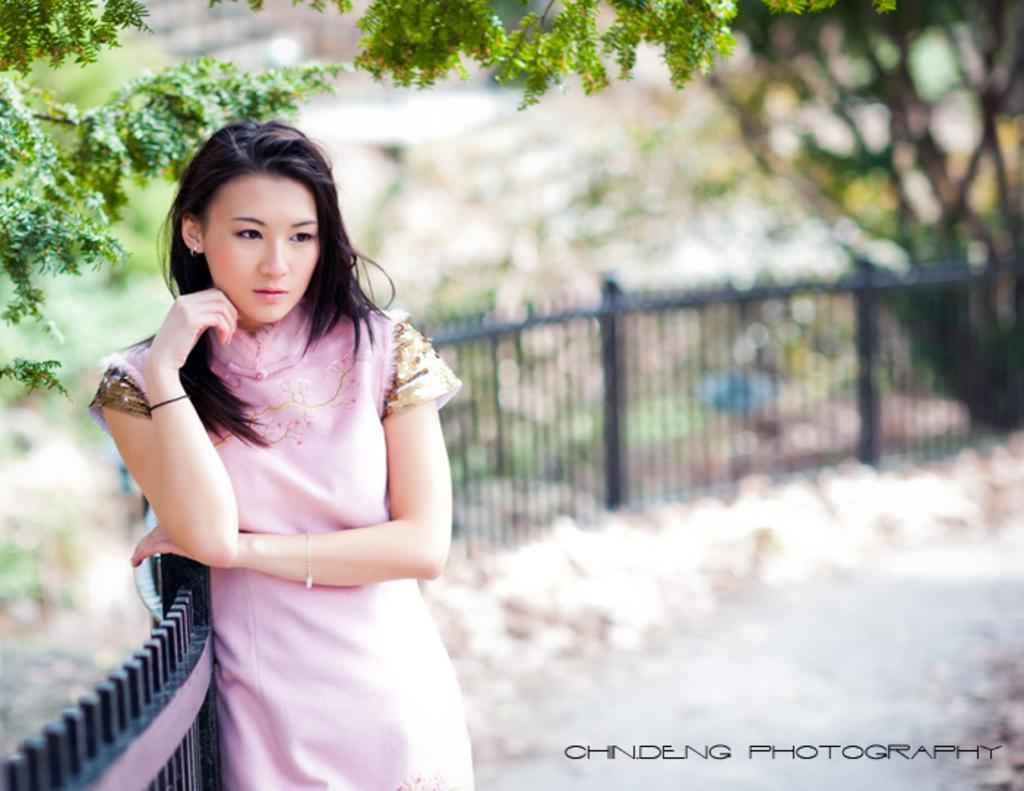Who is the main subject in the foreground of the image? There is a woman in the foreground of the image. What can be seen in the image besides the woman? There is fencing and trees in the image. What is visible in the background of the image? There are trees in the background of the image. What information is provided at the bottom of the image? There is text at the bottom of the image. How is the baby being treated in the image? There is no baby present in the image, so it is not possible to answer that question. 